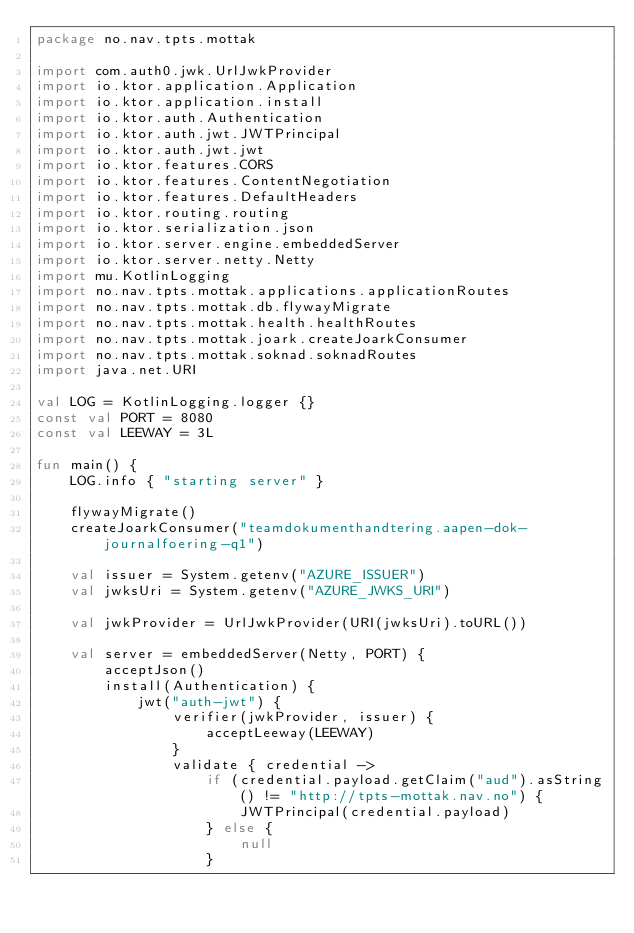Convert code to text. <code><loc_0><loc_0><loc_500><loc_500><_Kotlin_>package no.nav.tpts.mottak

import com.auth0.jwk.UrlJwkProvider
import io.ktor.application.Application
import io.ktor.application.install
import io.ktor.auth.Authentication
import io.ktor.auth.jwt.JWTPrincipal
import io.ktor.auth.jwt.jwt
import io.ktor.features.CORS
import io.ktor.features.ContentNegotiation
import io.ktor.features.DefaultHeaders
import io.ktor.routing.routing
import io.ktor.serialization.json
import io.ktor.server.engine.embeddedServer
import io.ktor.server.netty.Netty
import mu.KotlinLogging
import no.nav.tpts.mottak.applications.applicationRoutes
import no.nav.tpts.mottak.db.flywayMigrate
import no.nav.tpts.mottak.health.healthRoutes
import no.nav.tpts.mottak.joark.createJoarkConsumer
import no.nav.tpts.mottak.soknad.soknadRoutes
import java.net.URI

val LOG = KotlinLogging.logger {}
const val PORT = 8080
const val LEEWAY = 3L

fun main() {
    LOG.info { "starting server" }

    flywayMigrate()
    createJoarkConsumer("teamdokumenthandtering.aapen-dok-journalfoering-q1")

    val issuer = System.getenv("AZURE_ISSUER")
    val jwksUri = System.getenv("AZURE_JWKS_URI")

    val jwkProvider = UrlJwkProvider(URI(jwksUri).toURL())

    val server = embeddedServer(Netty, PORT) {
        acceptJson()
        install(Authentication) {
            jwt("auth-jwt") {
                verifier(jwkProvider, issuer) {
                    acceptLeeway(LEEWAY)
                }
                validate { credential ->
                    if (credential.payload.getClaim("aud").asString() != "http://tpts-mottak.nav.no") {
                        JWTPrincipal(credential.payload)
                    } else {
                        null
                    }</code> 